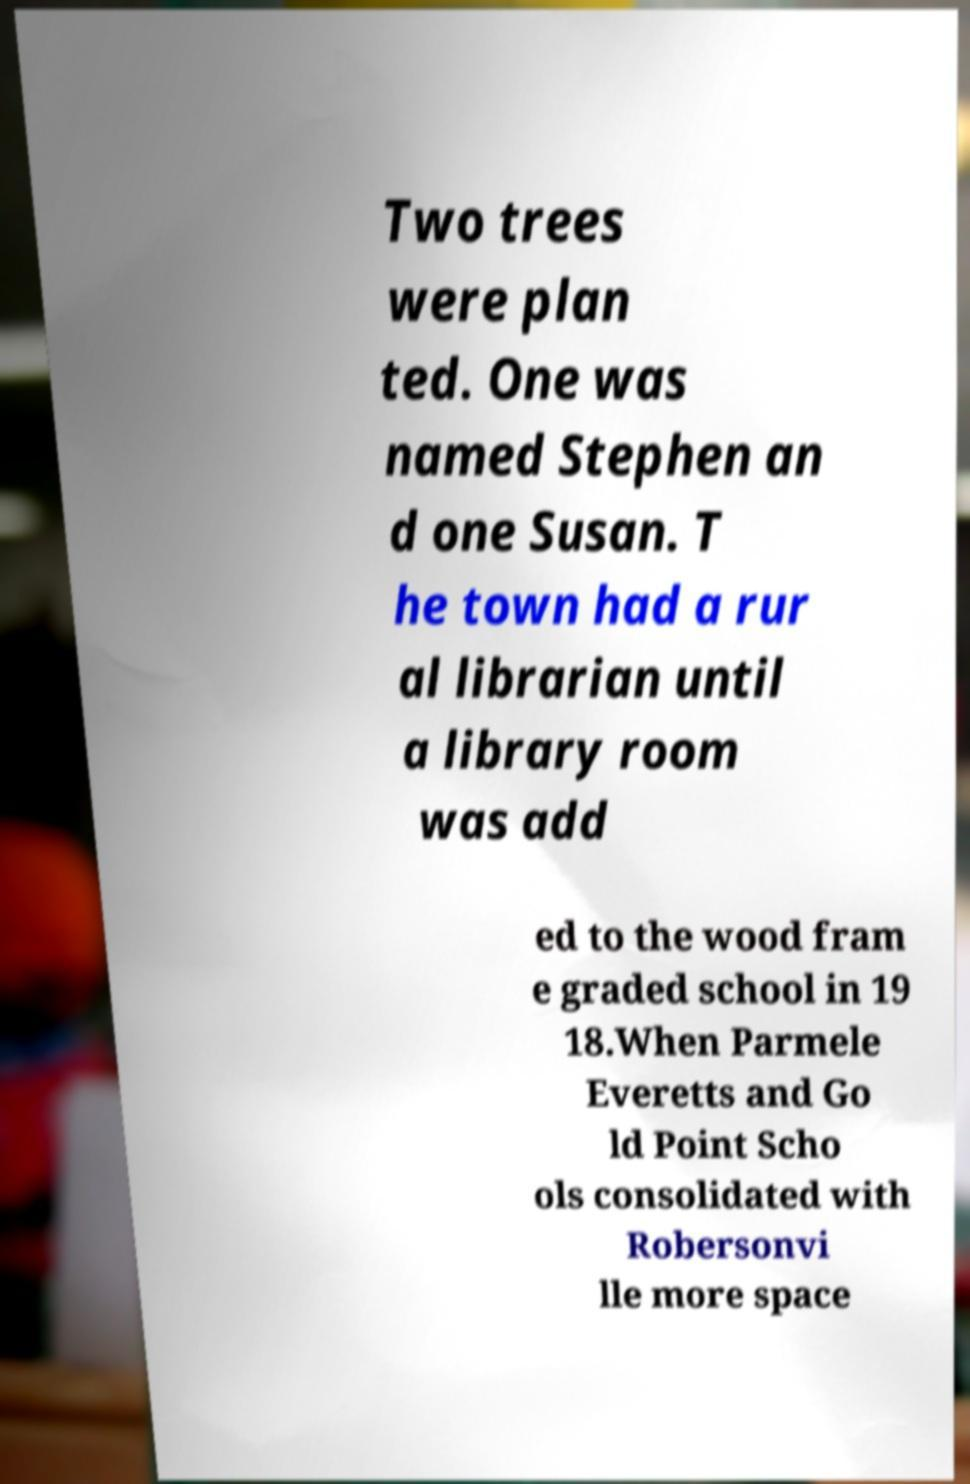For documentation purposes, I need the text within this image transcribed. Could you provide that? Two trees were plan ted. One was named Stephen an d one Susan. T he town had a rur al librarian until a library room was add ed to the wood fram e graded school in 19 18.When Parmele Everetts and Go ld Point Scho ols consolidated with Robersonvi lle more space 